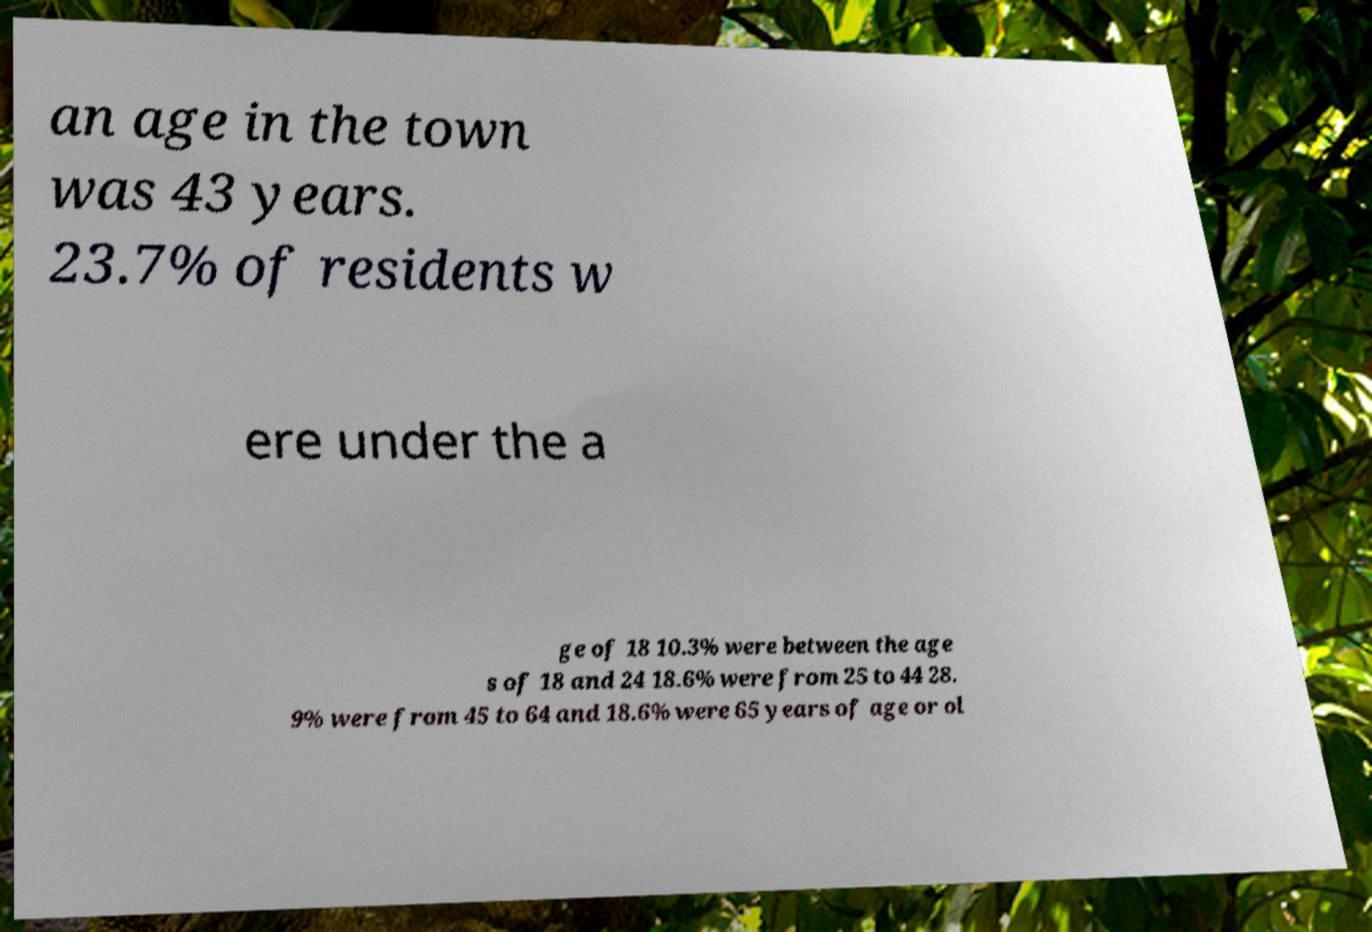For documentation purposes, I need the text within this image transcribed. Could you provide that? an age in the town was 43 years. 23.7% of residents w ere under the a ge of 18 10.3% were between the age s of 18 and 24 18.6% were from 25 to 44 28. 9% were from 45 to 64 and 18.6% were 65 years of age or ol 